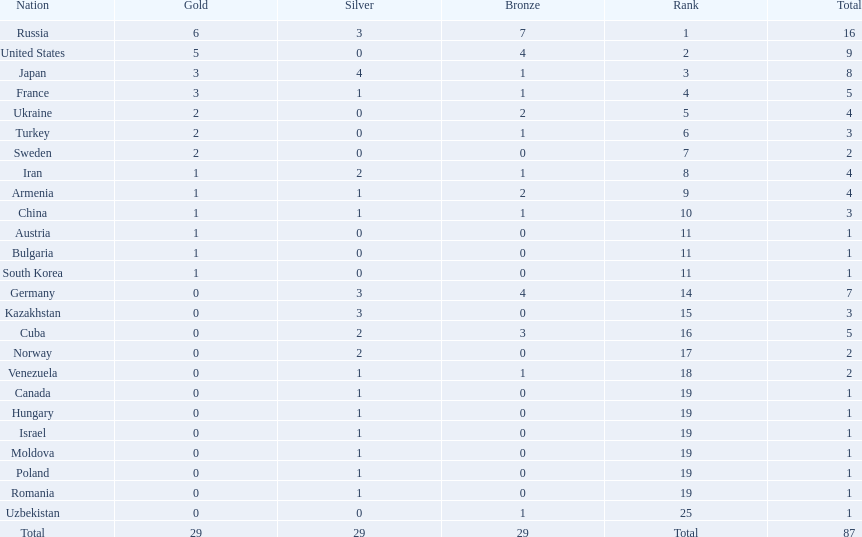Where did iran rank? 8. Where did germany rank? 14. Which of those did make it into the top 10 rank? Germany. 